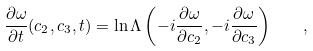Convert formula to latex. <formula><loc_0><loc_0><loc_500><loc_500>\frac { \partial \omega } { \partial t } ( c _ { 2 } , c _ { 3 } , t ) = \ln \Lambda \left ( - i \frac { \partial \omega } { \partial c _ { 2 } } , - i \frac { \partial \omega } { \partial c _ { 3 } } \right ) \quad ,</formula> 